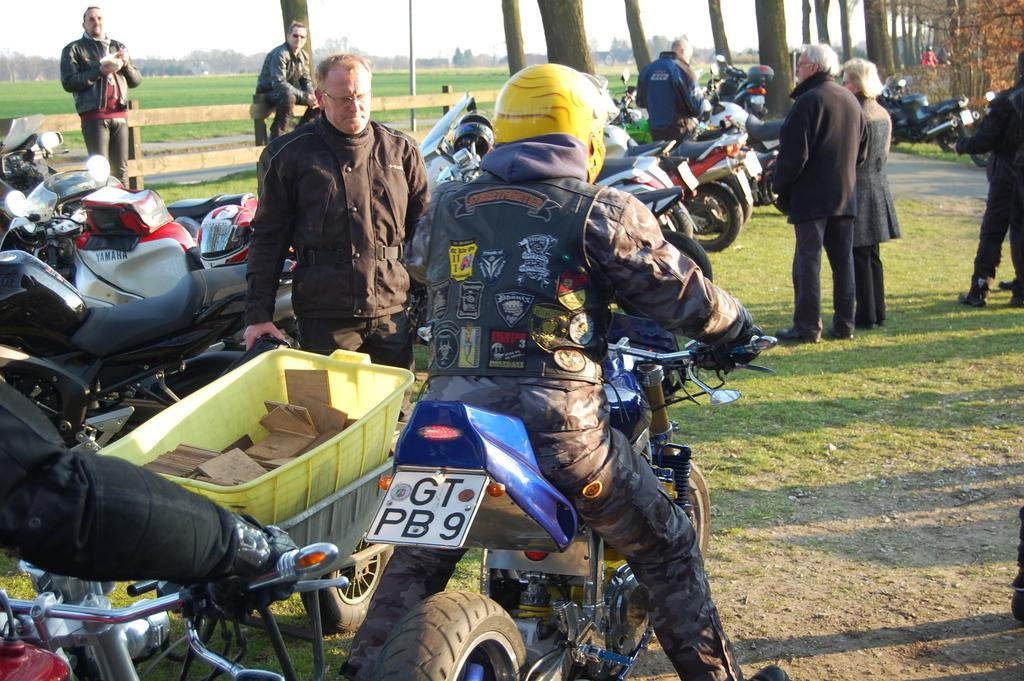What is the man in the image wearing on his head? The man is wearing a helmet in the image. What is the man sitting on in the image? The man is sitting on a motorbike in the image. How many motorbikes can be seen in the image? There are motorbikes parked in the image. What are the people in the image doing? There are people standing in the image. What can be seen in the background of the image? There are trees in the background of the image. How many chairs are visible in the image? There are no chairs visible in the image. What type of respect is being shown in the image? The image does not depict any specific type of respect; it shows a man on a motorbike and other people standing nearby. 